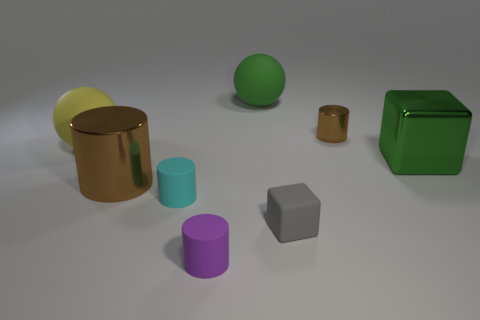The tiny shiny object that is the same color as the big metallic cylinder is what shape?
Offer a very short reply. Cylinder. What is the shape of the brown metal thing that is the same size as the yellow matte sphere?
Provide a succinct answer. Cylinder. The brown metal object that is behind the cube behind the small rubber object to the right of the large green ball is what shape?
Give a very brief answer. Cylinder. There is a small purple object; is its shape the same as the large metal thing that is on the left side of the big green matte sphere?
Make the answer very short. Yes. How many big objects are either matte spheres or brown things?
Provide a succinct answer. 3. Is there a green matte sphere that has the same size as the cyan object?
Your response must be concise. No. The tiny object that is behind the cube that is behind the brown thing that is in front of the tiny brown cylinder is what color?
Give a very brief answer. Brown. Is the cyan cylinder made of the same material as the big brown cylinder in front of the big green rubber thing?
Keep it short and to the point. No. What is the size of the other cyan thing that is the same shape as the small shiny object?
Make the answer very short. Small. Are there the same number of cylinders that are to the right of the big brown cylinder and small gray matte blocks in front of the purple rubber thing?
Provide a succinct answer. No. 